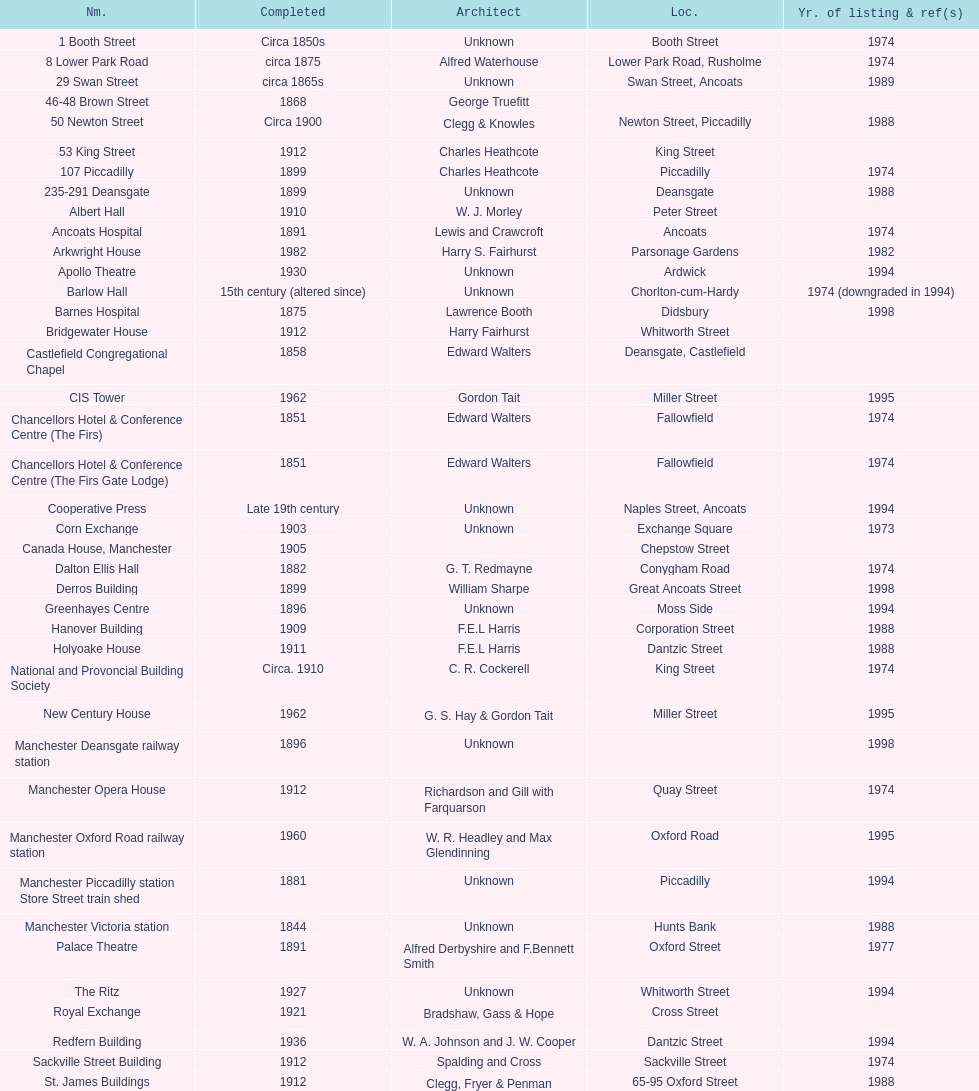What is the street of the only building listed in 1989? Swan Street. 